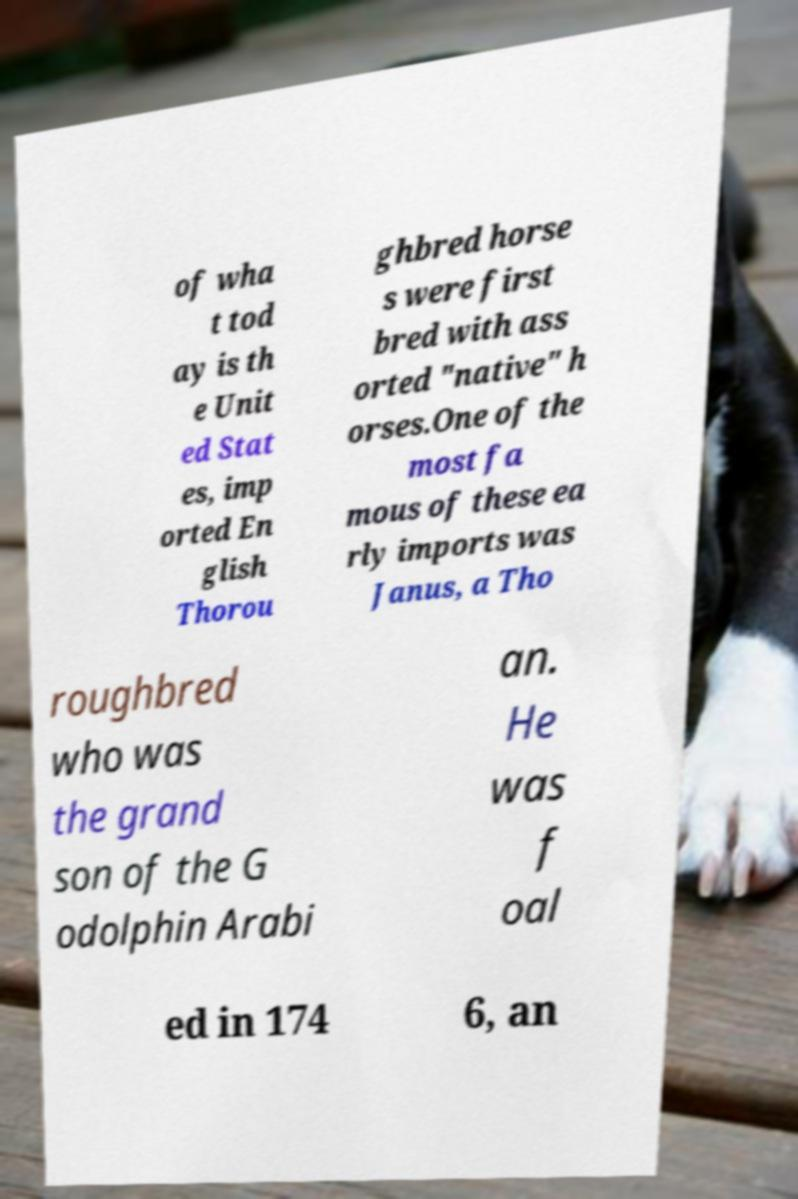Could you extract and type out the text from this image? of wha t tod ay is th e Unit ed Stat es, imp orted En glish Thorou ghbred horse s were first bred with ass orted "native" h orses.One of the most fa mous of these ea rly imports was Janus, a Tho roughbred who was the grand son of the G odolphin Arabi an. He was f oal ed in 174 6, an 